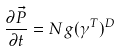<formula> <loc_0><loc_0><loc_500><loc_500>\frac { \partial \vec { P } } { \partial t } = N g ( \gamma ^ { T } ) ^ { D }</formula> 